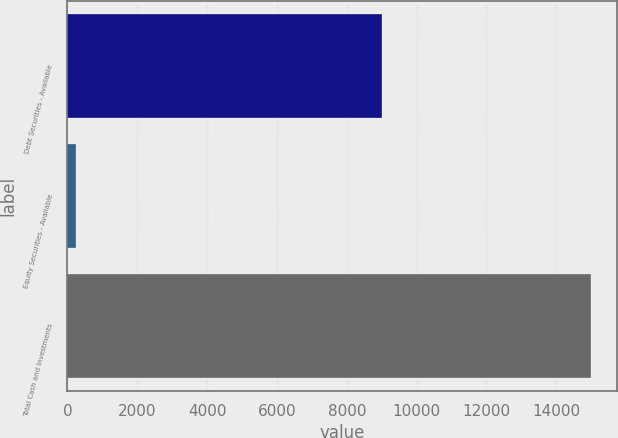Convert chart to OTSL. <chart><loc_0><loc_0><loc_500><loc_500><bar_chart><fcel>Debt Securities - Available<fcel>Equity Securities - Available<fcel>Total Cash and Investments<nl><fcel>9019<fcel>261<fcel>14982<nl></chart> 